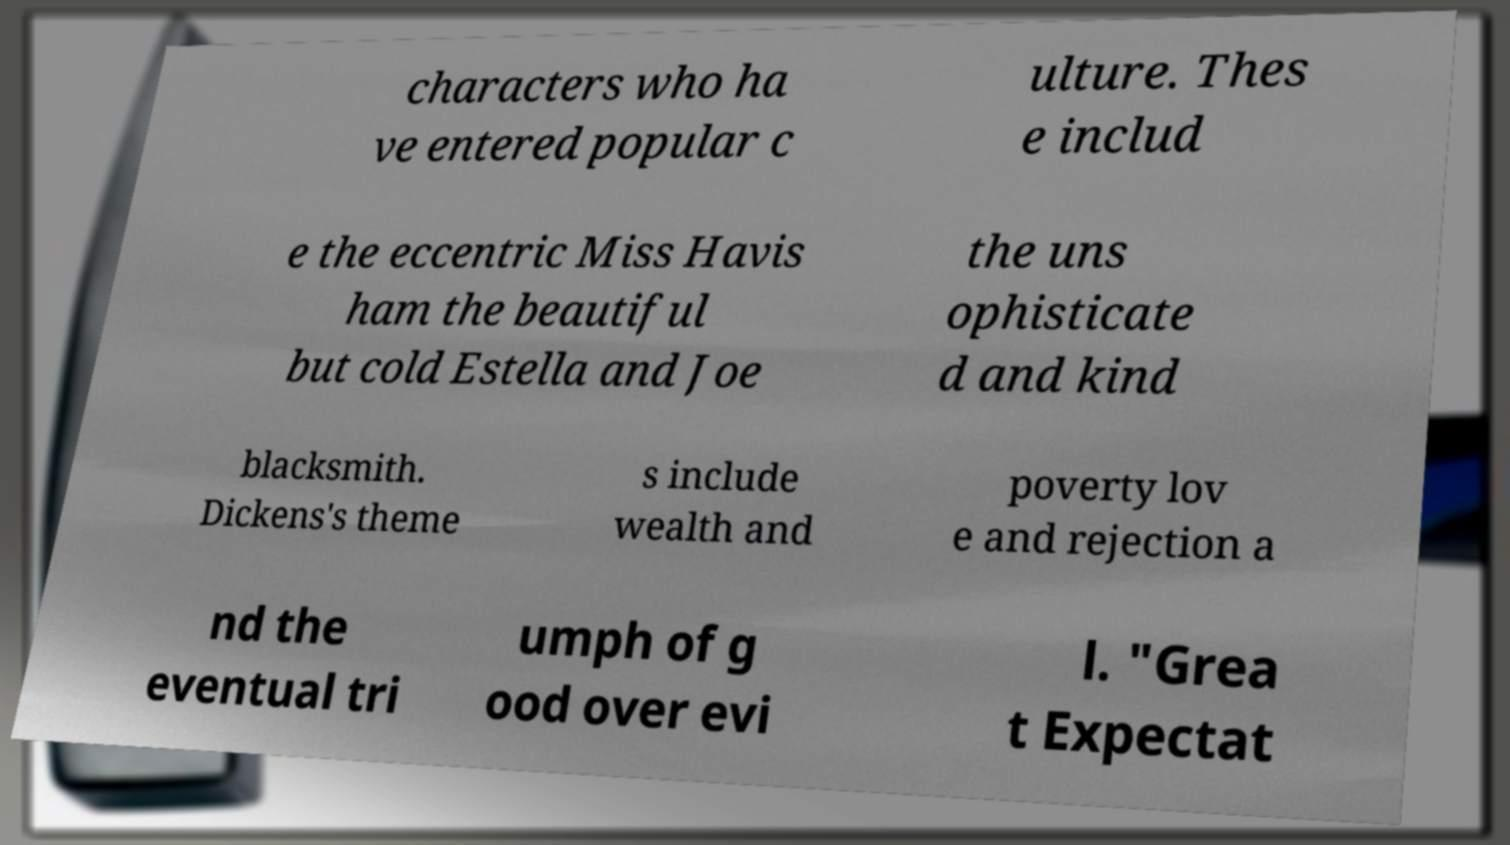What messages or text are displayed in this image? I need them in a readable, typed format. characters who ha ve entered popular c ulture. Thes e includ e the eccentric Miss Havis ham the beautiful but cold Estella and Joe the uns ophisticate d and kind blacksmith. Dickens's theme s include wealth and poverty lov e and rejection a nd the eventual tri umph of g ood over evi l. "Grea t Expectat 